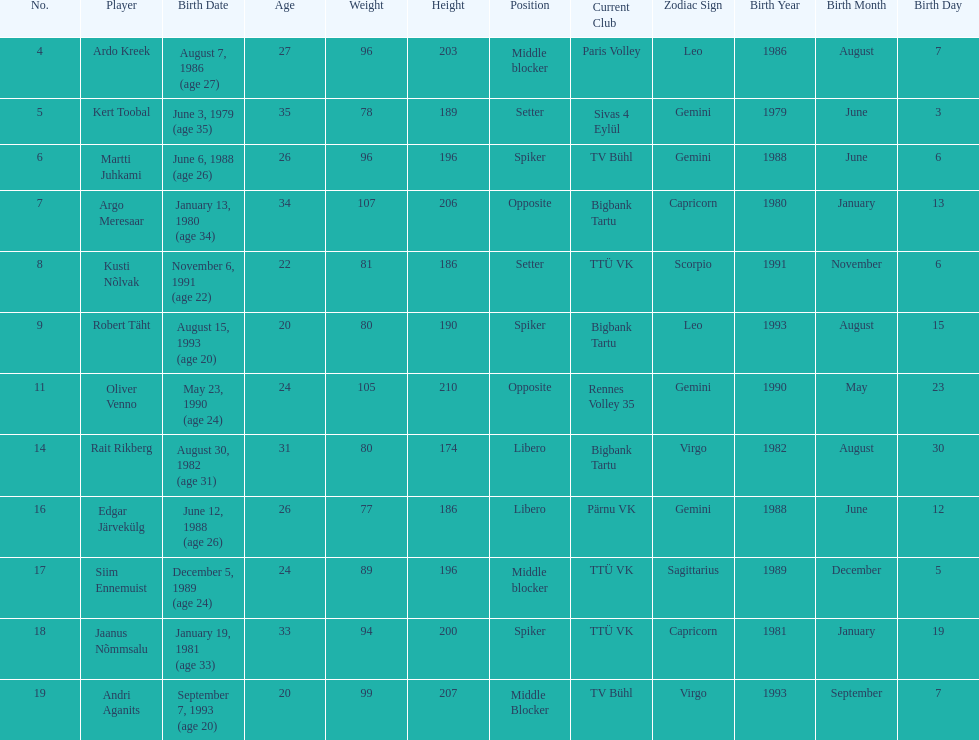What are the total number of players from france? 2. 